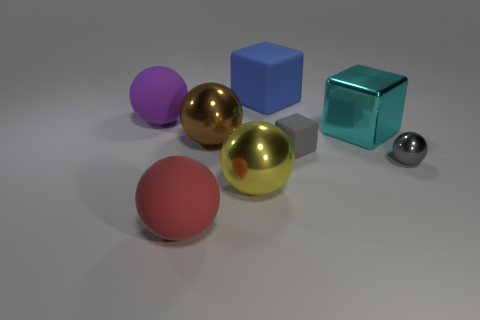Is the material of the big cyan thing behind the tiny metallic ball the same as the large ball that is to the left of the large red rubber thing?
Make the answer very short. No. What number of red matte objects have the same shape as the cyan thing?
Give a very brief answer. 0. There is a sphere that is the same color as the small cube; what is its material?
Your answer should be compact. Metal. What number of objects are either small cyan things or matte objects that are on the right side of the red rubber ball?
Give a very brief answer. 2. What material is the brown ball?
Your response must be concise. Metal. What material is the big brown thing that is the same shape as the big yellow metallic object?
Your answer should be compact. Metal. The small object to the left of the object right of the cyan object is what color?
Keep it short and to the point. Gray. What number of matte things are yellow spheres or large purple balls?
Your answer should be very brief. 1. Are the big brown thing and the blue thing made of the same material?
Your response must be concise. No. There is a small gray thing left of the big metal object behind the big brown metallic ball; what is it made of?
Your answer should be compact. Rubber. 